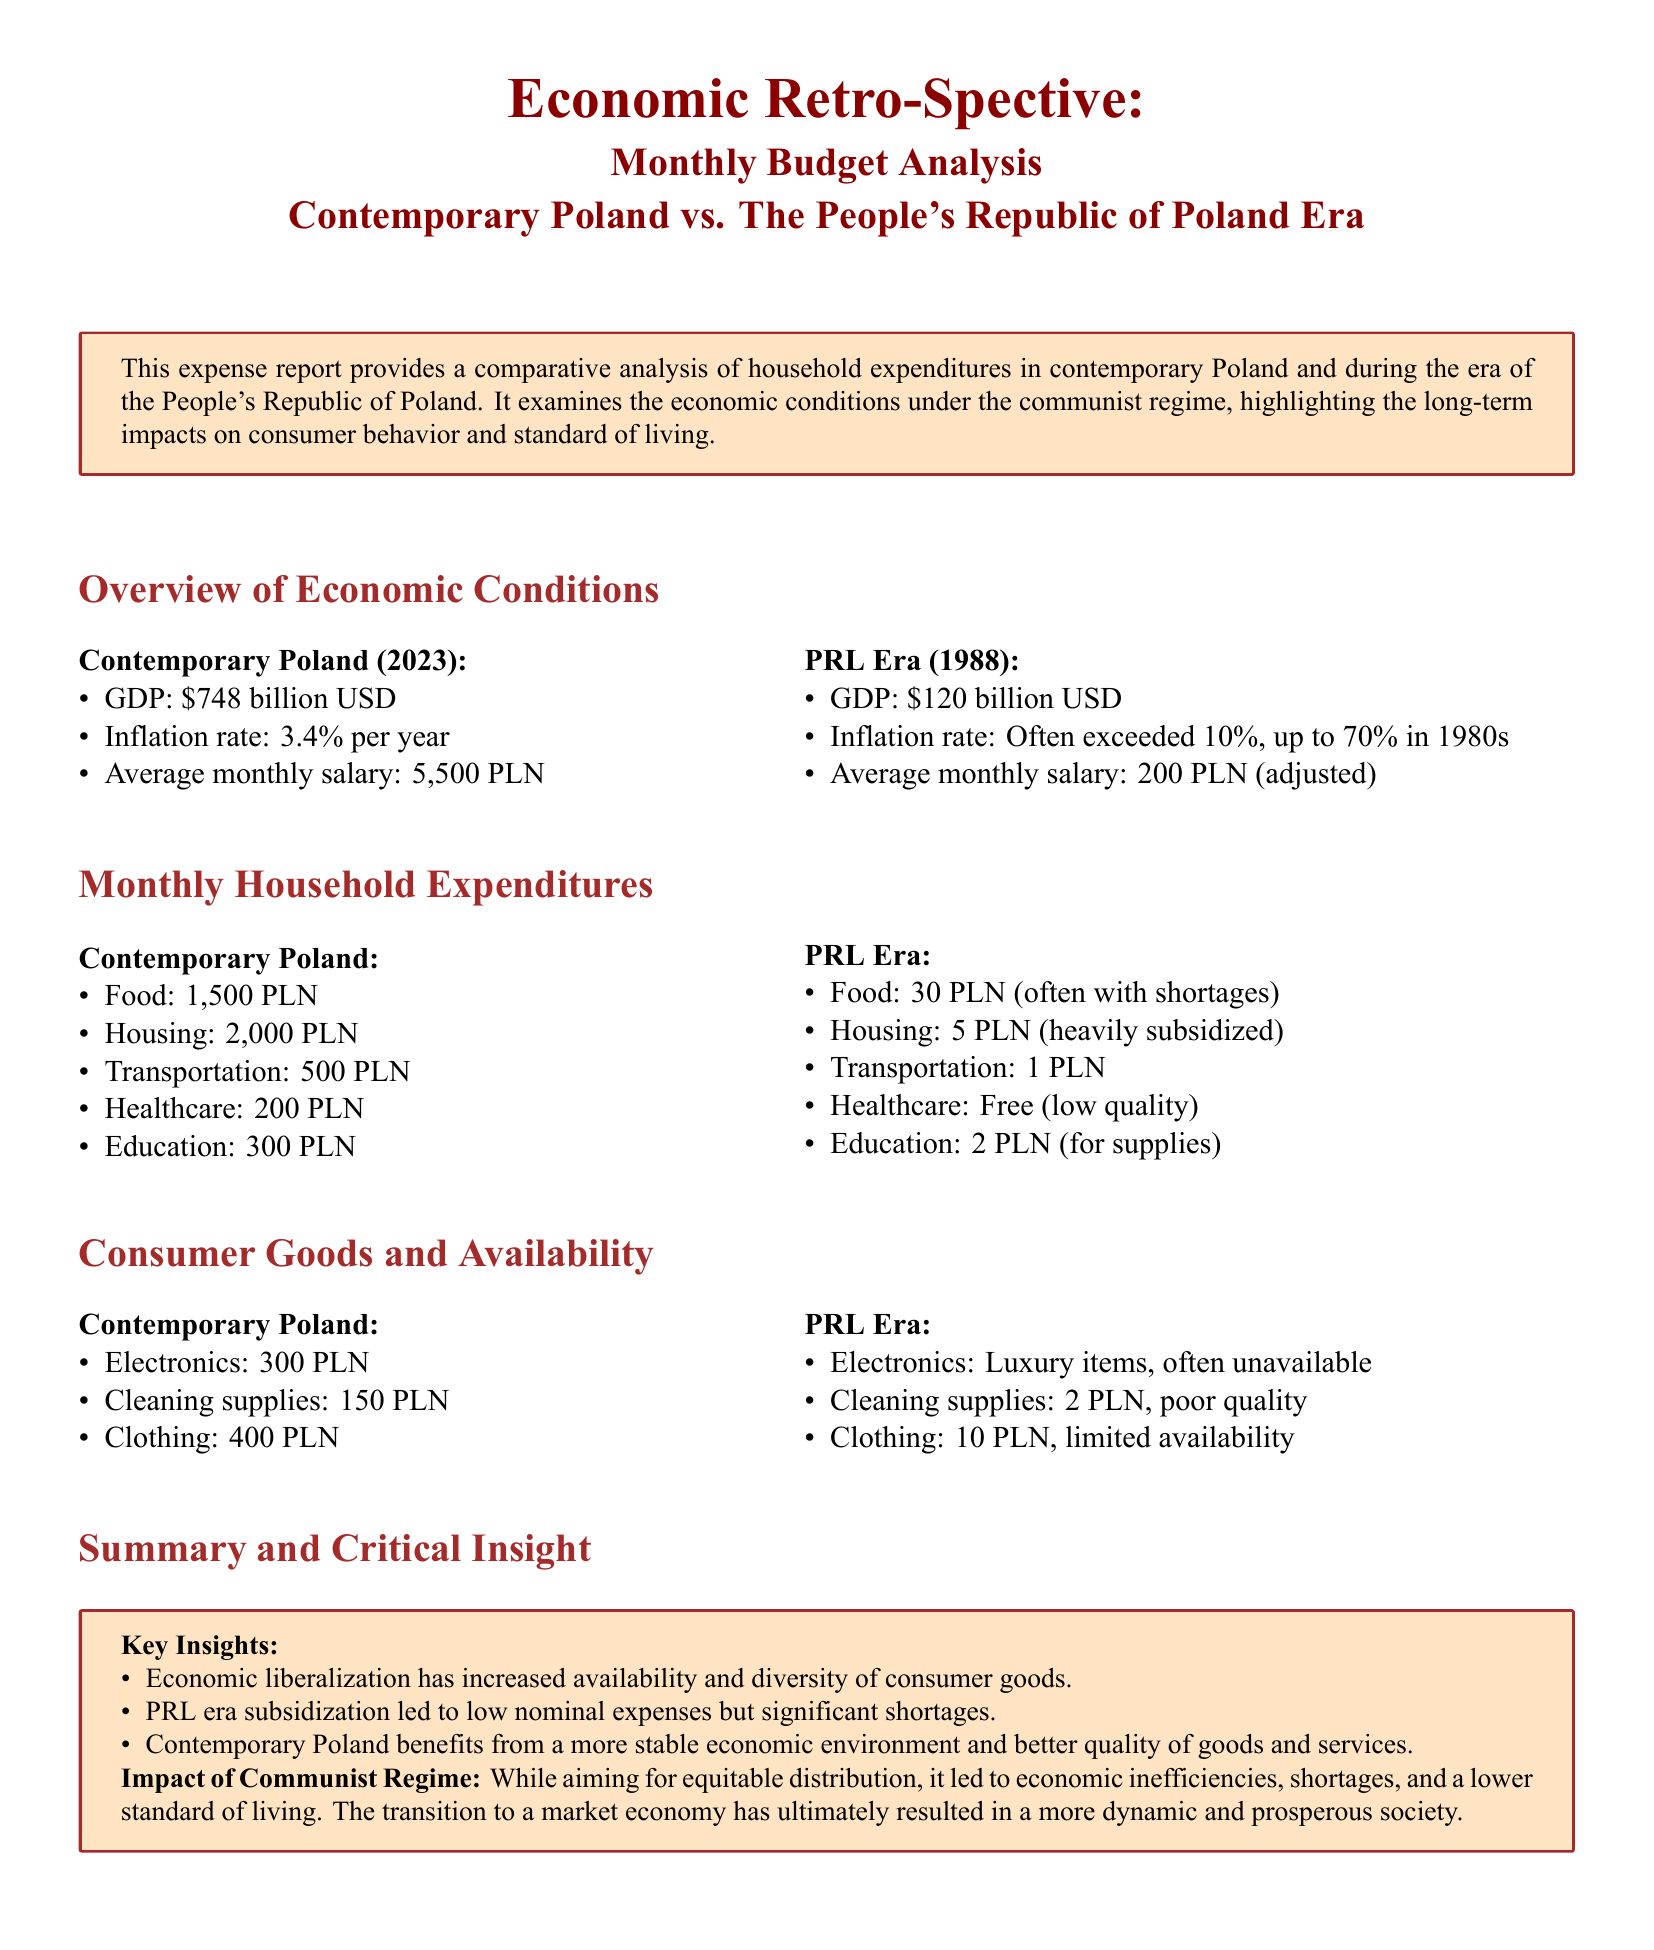What was the average monthly salary in contemporary Poland? The average monthly salary in contemporary Poland is stated as 5,500 PLN.
Answer: 5,500 PLN What was the inflation rate in the PRL era? The document indicates that the inflation rate often exceeded 10%, reaching up to 70% in the 1980s.
Answer: Exceeded 10% What is the monthly expenditure on housing in contemporary Poland? The report lists the expenditure on housing in contemporary Poland as 2,000 PLN.
Answer: 2,000 PLN How much was the average monthly salary adjusted for the PRL era? The adjusted average monthly salary in the PRL era is stated as 200 PLN.
Answer: 200 PLN What were healthcare expenses in the PRL era? The document states that healthcare was free in the PRL era, although it mentions low quality.
Answer: Free What does the report indicate about the availability of electronics in the PRL era? The report notes that electronics were luxury items and often unavailable during the PRL era.
Answer: Often unavailable What was the cost of clothing in contemporary Poland? The cost of clothing in contemporary Poland is mentioned as 400 PLN.
Answer: 400 PLN How did the PRL era subsidization impact consumer behavior? The report explains that PRL era subsidization led to low nominal expenses but significant shortages.
Answer: Significant shortages What is highlighted as a key insight regarding contemporary Poland? A key insight is that economic liberalization has increased availability and diversity of consumer goods.
Answer: Increased availability and diversity 